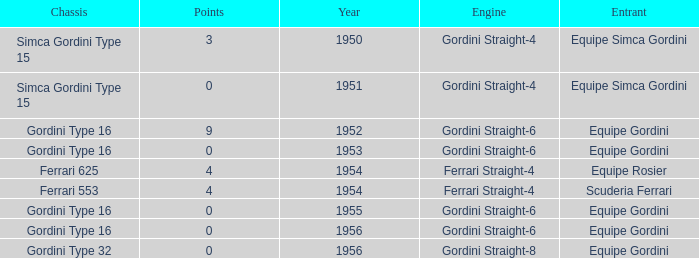What engine was used by Equipe Simca Gordini before 1956 with less than 4 points? Gordini Straight-4, Gordini Straight-4. 